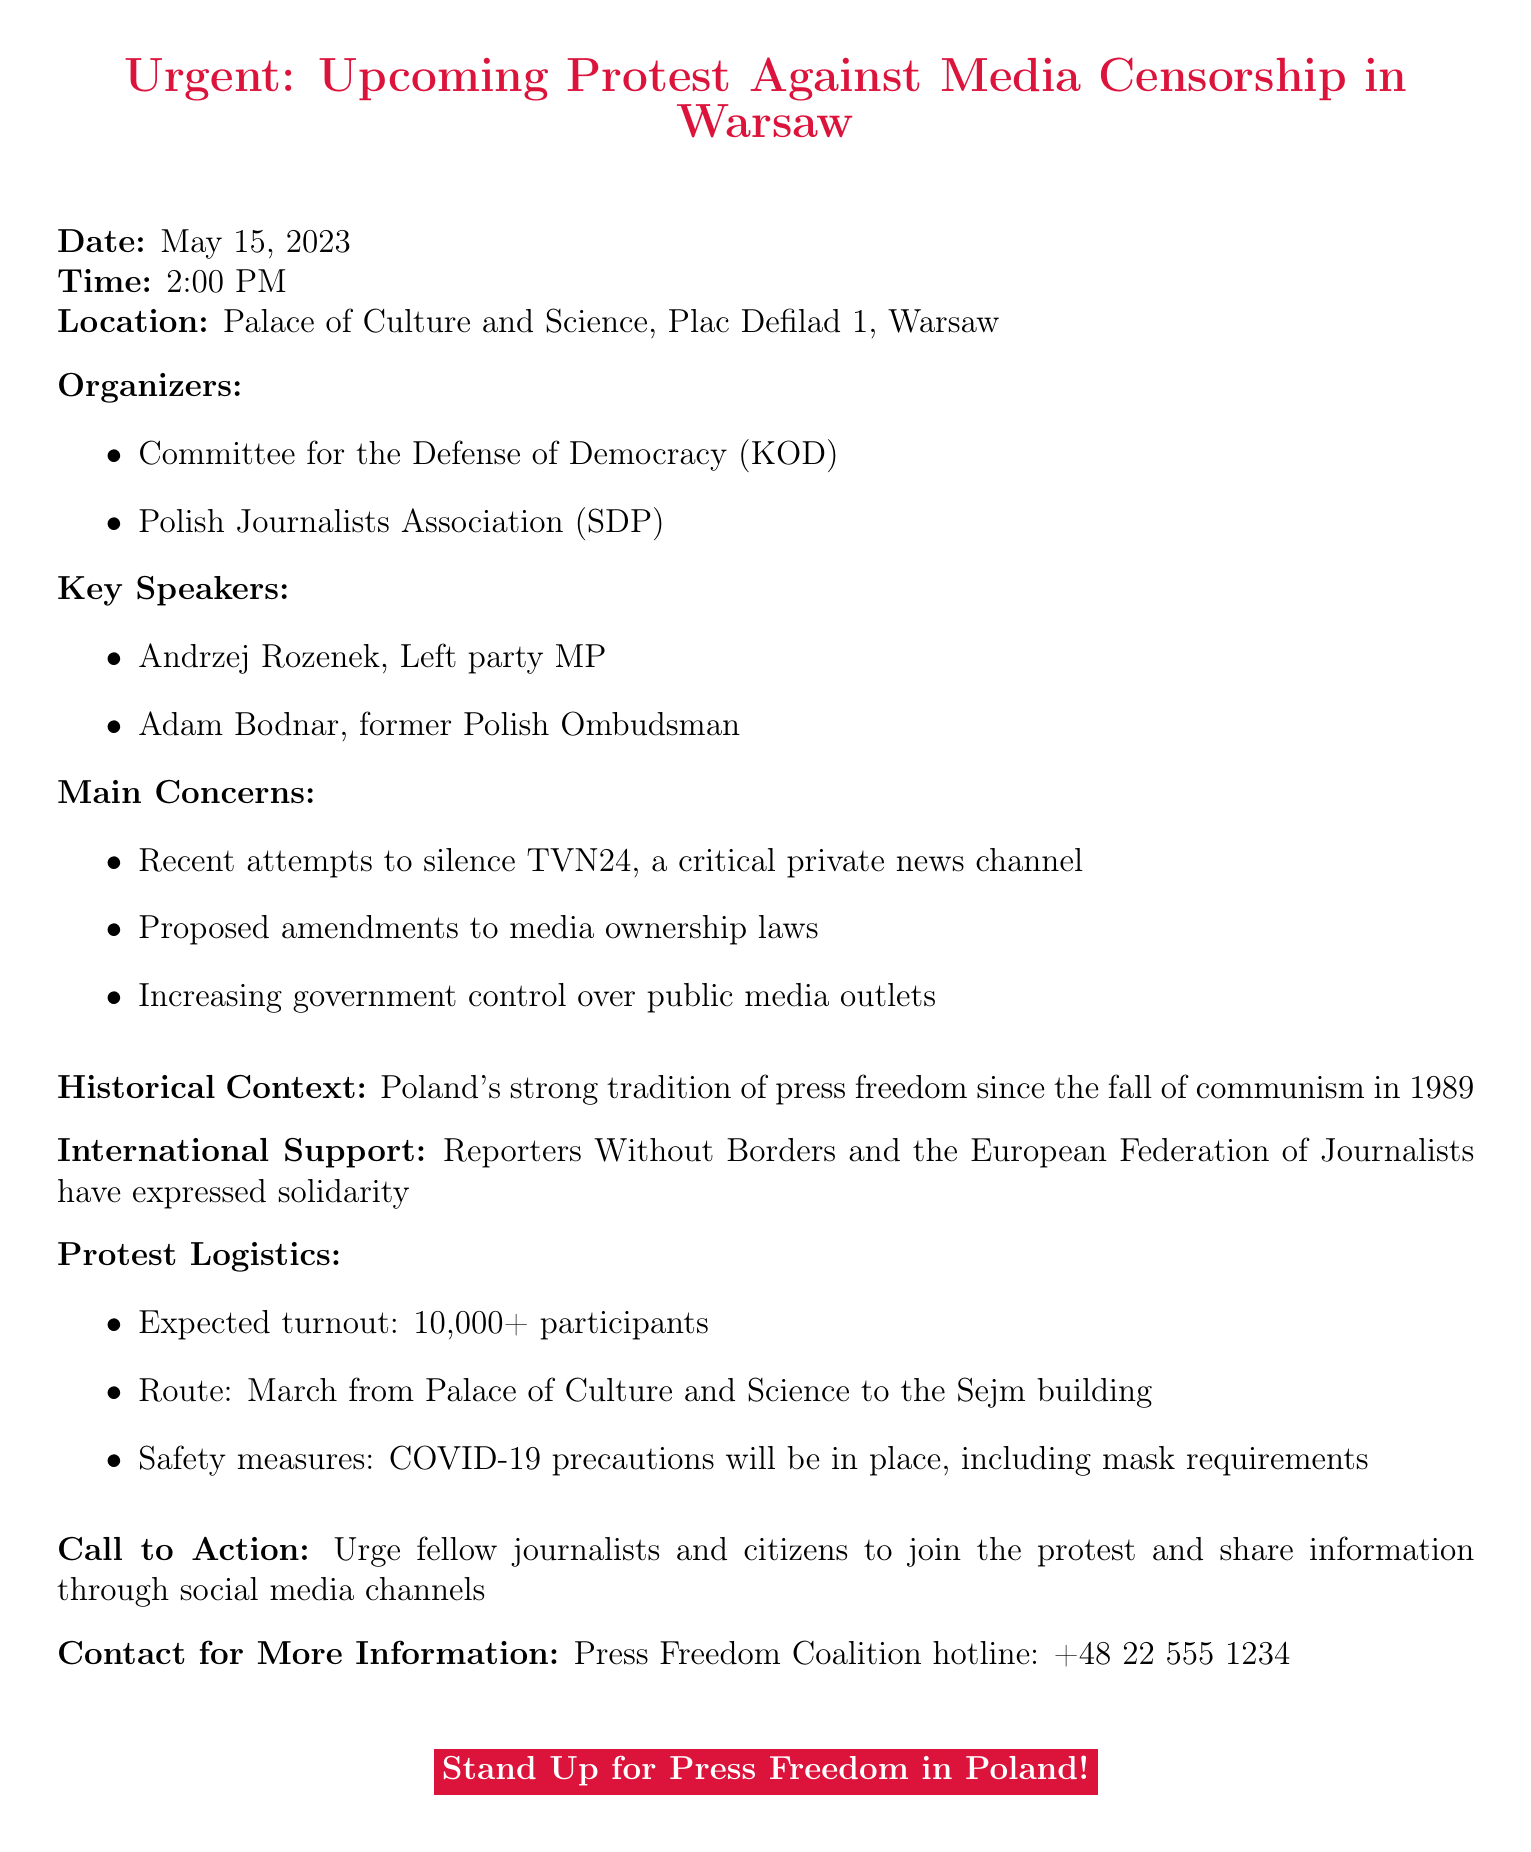what is the date of the protest? The document states that the protest is scheduled for May 15, 2023.
Answer: May 15, 2023 what time does the protest start? The document indicates that the protest will begin at 2:00 PM.
Answer: 2:00 PM where is the protest taking place? The location for the protest is identified as the Palace of Culture and Science, Plac Defilad 1, Warsaw.
Answer: Palace of Culture and Science, Plac Defilad 1, Warsaw who is one of the key speakers at the protest? The document lists Andrzej Rozenek as one of the key speakers for the protest.
Answer: Andrzej Rozenek what is a main concern mentioned in the document? One of the main concerns highlighted is the attempts to silence TVN24.
Answer: Recent attempts to silence TVN24 how many participants are expected at the protest? According to the document, more than 10,000 participants are expected to attend the protest.
Answer: 10,000+ what is the route of the march? The document specifies the route as a march from the Palace of Culture and Science to the Sejm building.
Answer: March from Palace of Culture and Science to the Sejm building who are the organizers of the protest? The organizers mentioned in the document are the Committee for the Defense of Democracy (KOD) and the Polish Journalists Association (SDP).
Answer: Committee for the Defense of Democracy (KOD), Polish Journalists Association (SDP) what is the historical context mentioned? The document notes Poland's strong tradition of press freedom since the fall of communism in 1989 as part of the historical context.
Answer: Poland's strong tradition of press freedom since the fall of communism in 1989 